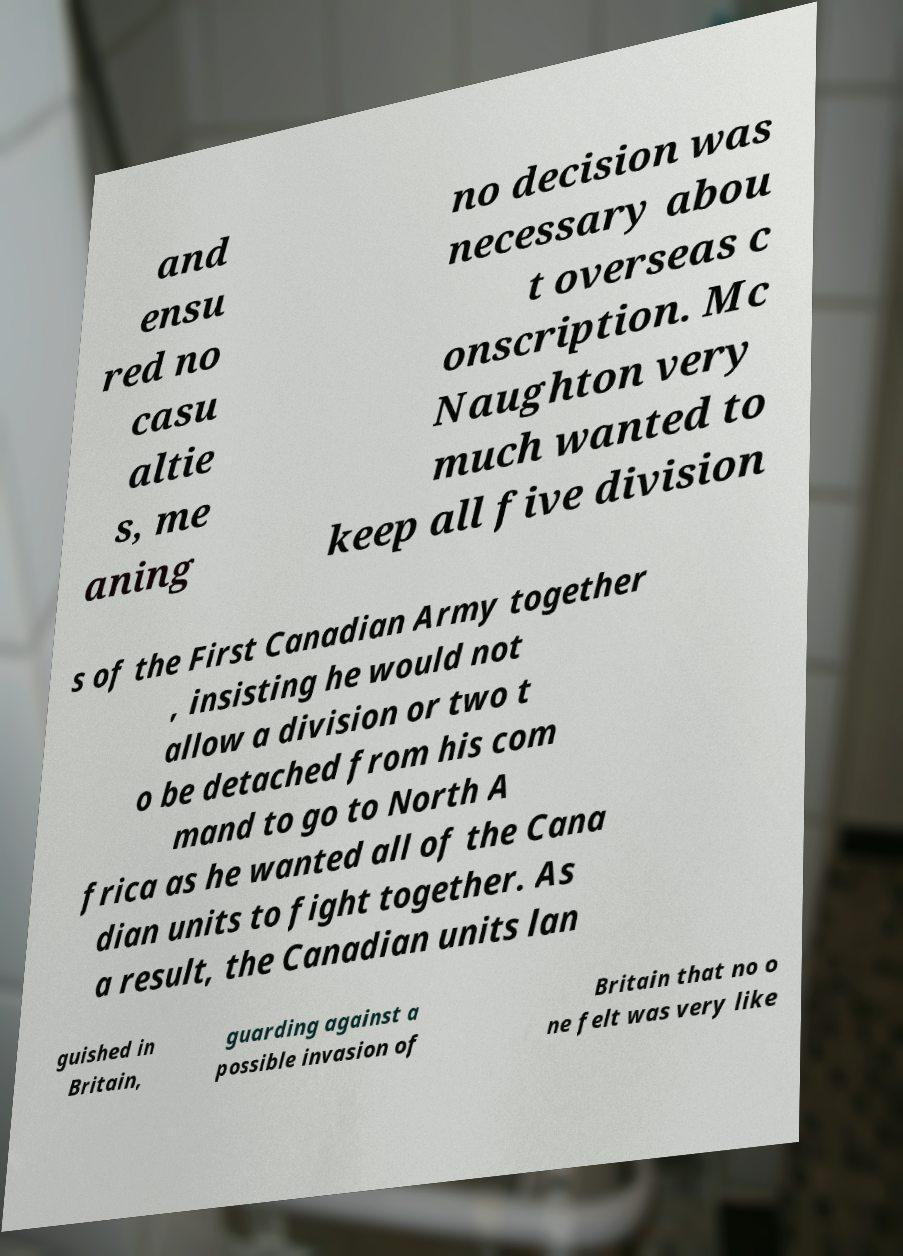There's text embedded in this image that I need extracted. Can you transcribe it verbatim? and ensu red no casu altie s, me aning no decision was necessary abou t overseas c onscription. Mc Naughton very much wanted to keep all five division s of the First Canadian Army together , insisting he would not allow a division or two t o be detached from his com mand to go to North A frica as he wanted all of the Cana dian units to fight together. As a result, the Canadian units lan guished in Britain, guarding against a possible invasion of Britain that no o ne felt was very like 